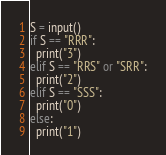Convert code to text. <code><loc_0><loc_0><loc_500><loc_500><_Python_>S = input()
if S == "RRR":
  print("3")
elif S == "RRS" or "SRR":
  print("2")
elif S == "SSS":
  print("0")
else:
  print("1")
</code> 